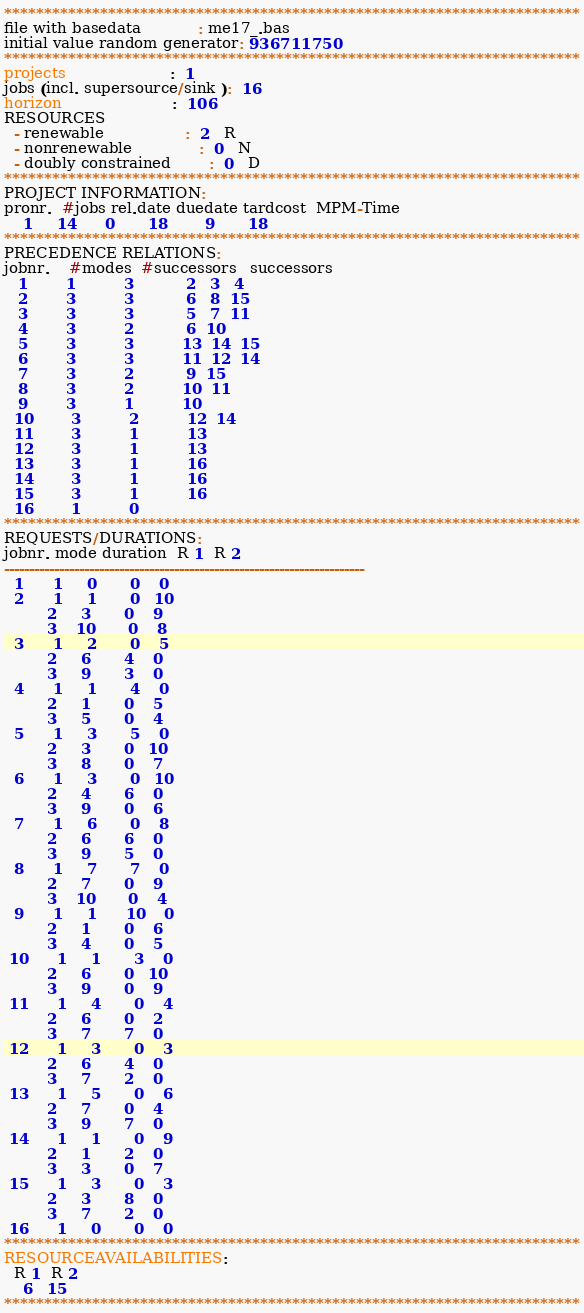<code> <loc_0><loc_0><loc_500><loc_500><_ObjectiveC_>************************************************************************
file with basedata            : me17_.bas
initial value random generator: 936711750
************************************************************************
projects                      :  1
jobs (incl. supersource/sink ):  16
horizon                       :  106
RESOURCES
  - renewable                 :  2   R
  - nonrenewable              :  0   N
  - doubly constrained        :  0   D
************************************************************************
PROJECT INFORMATION:
pronr.  #jobs rel.date duedate tardcost  MPM-Time
    1     14      0       18        9       18
************************************************************************
PRECEDENCE RELATIONS:
jobnr.    #modes  #successors   successors
   1        1          3           2   3   4
   2        3          3           6   8  15
   3        3          3           5   7  11
   4        3          2           6  10
   5        3          3          13  14  15
   6        3          3          11  12  14
   7        3          2           9  15
   8        3          2          10  11
   9        3          1          10
  10        3          2          12  14
  11        3          1          13
  12        3          1          13
  13        3          1          16
  14        3          1          16
  15        3          1          16
  16        1          0        
************************************************************************
REQUESTS/DURATIONS:
jobnr. mode duration  R 1  R 2
------------------------------------------------------------------------
  1      1     0       0    0
  2      1     1       0   10
         2     3       0    9
         3    10       0    8
  3      1     2       0    5
         2     6       4    0
         3     9       3    0
  4      1     1       4    0
         2     1       0    5
         3     5       0    4
  5      1     3       5    0
         2     3       0   10
         3     8       0    7
  6      1     3       0   10
         2     4       6    0
         3     9       0    6
  7      1     6       0    8
         2     6       6    0
         3     9       5    0
  8      1     7       7    0
         2     7       0    9
         3    10       0    4
  9      1     1      10    0
         2     1       0    6
         3     4       0    5
 10      1     1       3    0
         2     6       0   10
         3     9       0    9
 11      1     4       0    4
         2     6       0    2
         3     7       7    0
 12      1     3       0    3
         2     6       4    0
         3     7       2    0
 13      1     5       0    6
         2     7       0    4
         3     9       7    0
 14      1     1       0    9
         2     1       2    0
         3     3       0    7
 15      1     3       0    3
         2     3       8    0
         3     7       2    0
 16      1     0       0    0
************************************************************************
RESOURCEAVAILABILITIES:
  R 1  R 2
    6   15
************************************************************************
</code> 